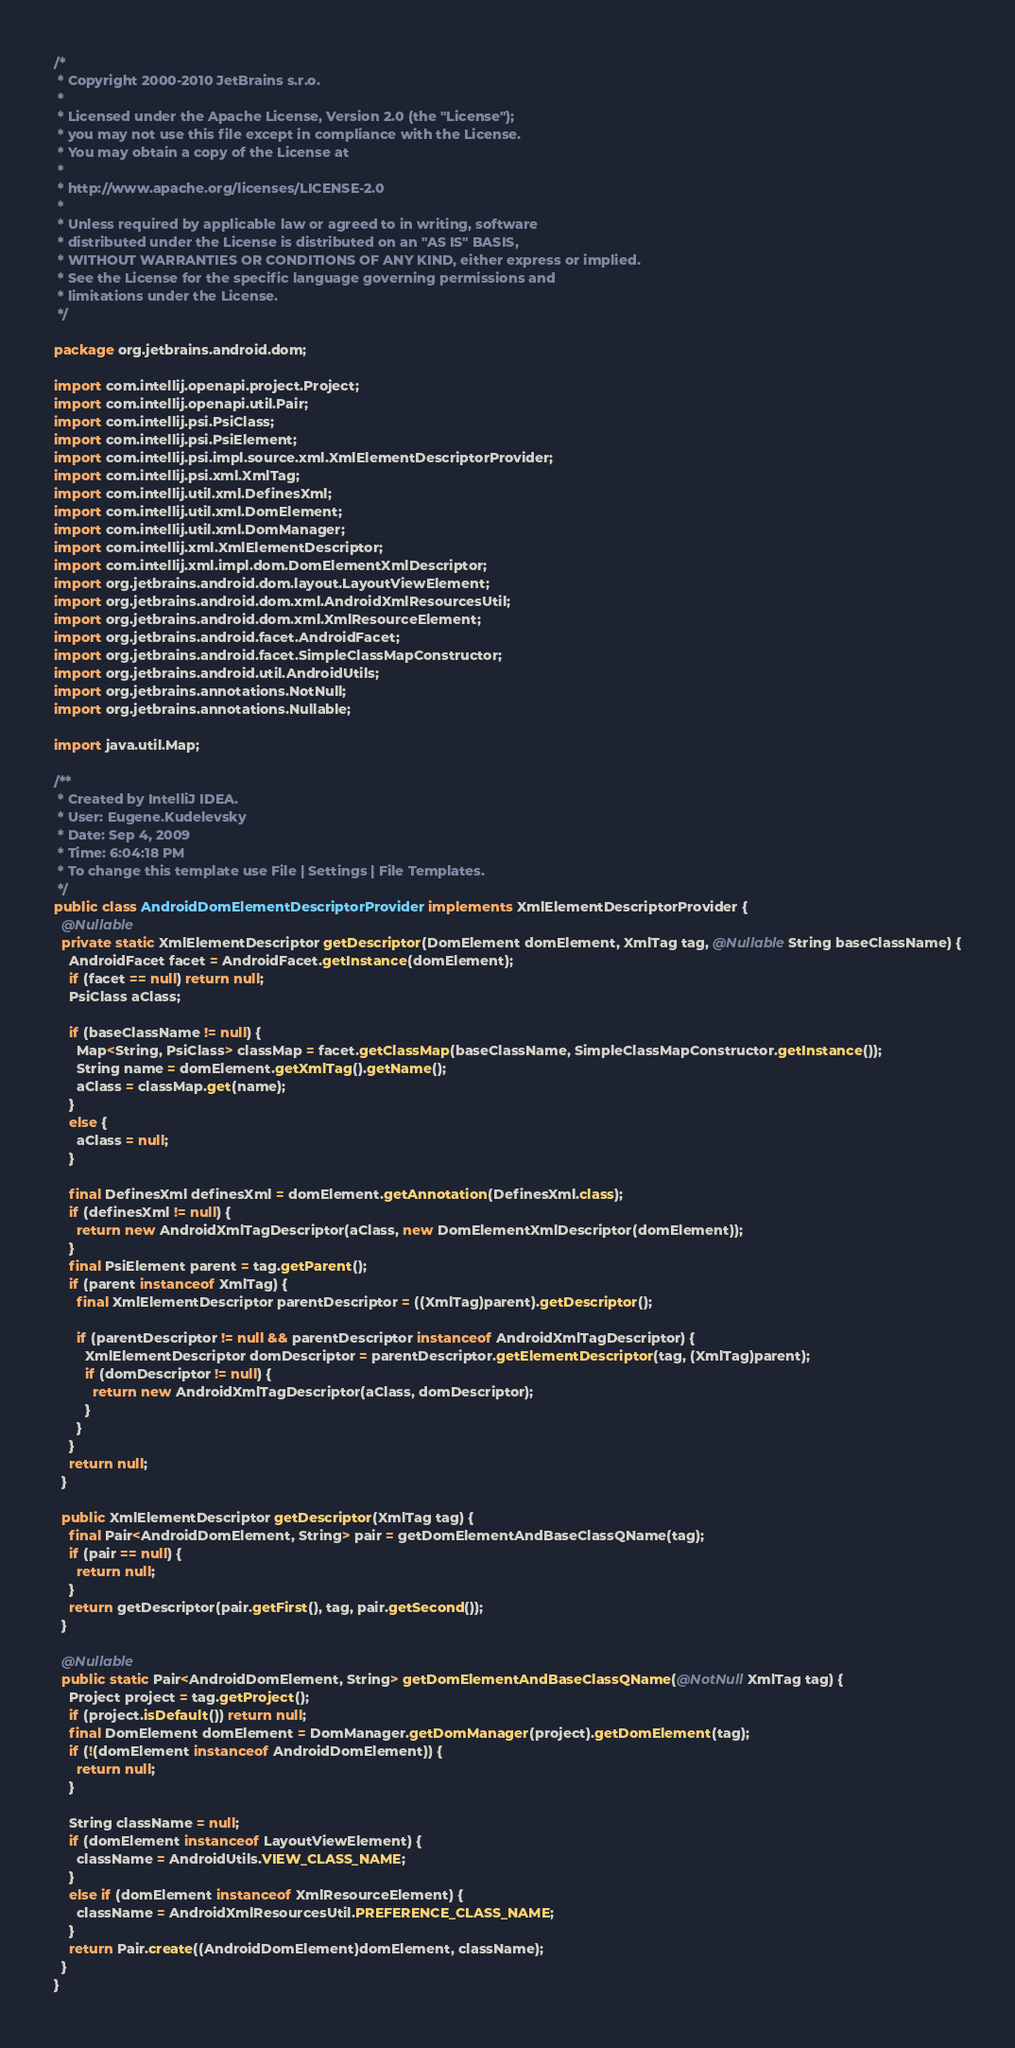Convert code to text. <code><loc_0><loc_0><loc_500><loc_500><_Java_>/*
 * Copyright 2000-2010 JetBrains s.r.o.
 *
 * Licensed under the Apache License, Version 2.0 (the "License");
 * you may not use this file except in compliance with the License.
 * You may obtain a copy of the License at
 *
 * http://www.apache.org/licenses/LICENSE-2.0
 *
 * Unless required by applicable law or agreed to in writing, software
 * distributed under the License is distributed on an "AS IS" BASIS,
 * WITHOUT WARRANTIES OR CONDITIONS OF ANY KIND, either express or implied.
 * See the License for the specific language governing permissions and
 * limitations under the License.
 */

package org.jetbrains.android.dom;

import com.intellij.openapi.project.Project;
import com.intellij.openapi.util.Pair;
import com.intellij.psi.PsiClass;
import com.intellij.psi.PsiElement;
import com.intellij.psi.impl.source.xml.XmlElementDescriptorProvider;
import com.intellij.psi.xml.XmlTag;
import com.intellij.util.xml.DefinesXml;
import com.intellij.util.xml.DomElement;
import com.intellij.util.xml.DomManager;
import com.intellij.xml.XmlElementDescriptor;
import com.intellij.xml.impl.dom.DomElementXmlDescriptor;
import org.jetbrains.android.dom.layout.LayoutViewElement;
import org.jetbrains.android.dom.xml.AndroidXmlResourcesUtil;
import org.jetbrains.android.dom.xml.XmlResourceElement;
import org.jetbrains.android.facet.AndroidFacet;
import org.jetbrains.android.facet.SimpleClassMapConstructor;
import org.jetbrains.android.util.AndroidUtils;
import org.jetbrains.annotations.NotNull;
import org.jetbrains.annotations.Nullable;

import java.util.Map;

/**
 * Created by IntelliJ IDEA.
 * User: Eugene.Kudelevsky
 * Date: Sep 4, 2009
 * Time: 6:04:18 PM
 * To change this template use File | Settings | File Templates.
 */
public class AndroidDomElementDescriptorProvider implements XmlElementDescriptorProvider {
  @Nullable
  private static XmlElementDescriptor getDescriptor(DomElement domElement, XmlTag tag, @Nullable String baseClassName) {
    AndroidFacet facet = AndroidFacet.getInstance(domElement);
    if (facet == null) return null;
    PsiClass aClass;

    if (baseClassName != null) {
      Map<String, PsiClass> classMap = facet.getClassMap(baseClassName, SimpleClassMapConstructor.getInstance());
      String name = domElement.getXmlTag().getName();
      aClass = classMap.get(name);
    }
    else {
      aClass = null;
    }

    final DefinesXml definesXml = domElement.getAnnotation(DefinesXml.class);
    if (definesXml != null) {
      return new AndroidXmlTagDescriptor(aClass, new DomElementXmlDescriptor(domElement));
    }
    final PsiElement parent = tag.getParent();
    if (parent instanceof XmlTag) {
      final XmlElementDescriptor parentDescriptor = ((XmlTag)parent).getDescriptor();

      if (parentDescriptor != null && parentDescriptor instanceof AndroidXmlTagDescriptor) {
        XmlElementDescriptor domDescriptor = parentDescriptor.getElementDescriptor(tag, (XmlTag)parent);
        if (domDescriptor != null) {
          return new AndroidXmlTagDescriptor(aClass, domDescriptor);
        }
      }
    }
    return null;
  }

  public XmlElementDescriptor getDescriptor(XmlTag tag) {
    final Pair<AndroidDomElement, String> pair = getDomElementAndBaseClassQName(tag);
    if (pair == null) {
      return null;
    }
    return getDescriptor(pair.getFirst(), tag, pair.getSecond());
  }

  @Nullable
  public static Pair<AndroidDomElement, String> getDomElementAndBaseClassQName(@NotNull XmlTag tag) {
    Project project = tag.getProject();
    if (project.isDefault()) return null;
    final DomElement domElement = DomManager.getDomManager(project).getDomElement(tag);
    if (!(domElement instanceof AndroidDomElement)) {
      return null;
    }

    String className = null;
    if (domElement instanceof LayoutViewElement) {
      className = AndroidUtils.VIEW_CLASS_NAME;
    }
    else if (domElement instanceof XmlResourceElement) {
      className = AndroidXmlResourcesUtil.PREFERENCE_CLASS_NAME;
    }
    return Pair.create((AndroidDomElement)domElement, className);
  }
}
</code> 